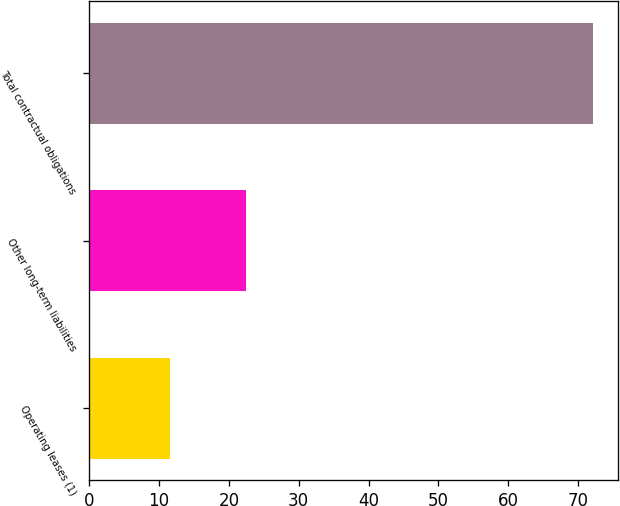Convert chart to OTSL. <chart><loc_0><loc_0><loc_500><loc_500><bar_chart><fcel>Operating leases (1)<fcel>Other long-term liabilities<fcel>Total contractual obligations<nl><fcel>11.6<fcel>22.4<fcel>72.1<nl></chart> 